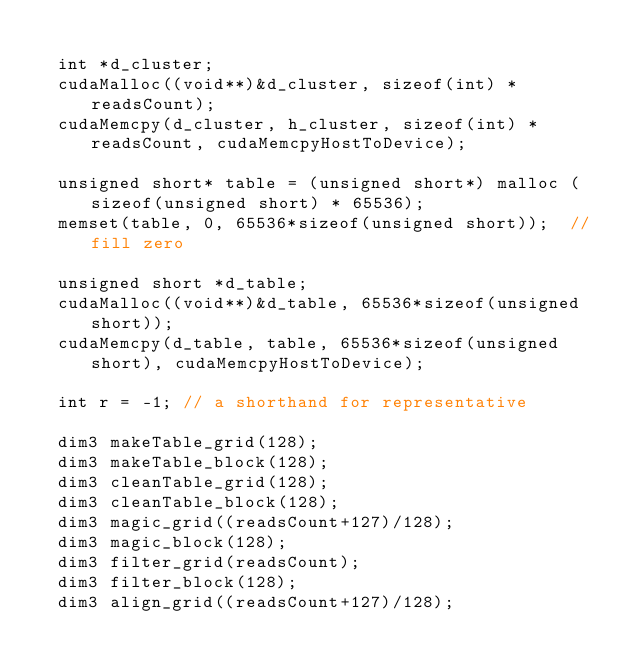<code> <loc_0><loc_0><loc_500><loc_500><_Cuda_>
  int *d_cluster;
  cudaMalloc((void**)&d_cluster, sizeof(int) * readsCount);
  cudaMemcpy(d_cluster, h_cluster, sizeof(int) * readsCount, cudaMemcpyHostToDevice);

  unsigned short* table = (unsigned short*) malloc (sizeof(unsigned short) * 65536);
  memset(table, 0, 65536*sizeof(unsigned short));  // fill zero

  unsigned short *d_table;
  cudaMalloc((void**)&d_table, 65536*sizeof(unsigned short));
  cudaMemcpy(d_table, table, 65536*sizeof(unsigned short), cudaMemcpyHostToDevice);

  int r = -1; // a shorthand for representative

  dim3 makeTable_grid(128);
  dim3 makeTable_block(128);
  dim3 cleanTable_grid(128);
  dim3 cleanTable_block(128);
  dim3 magic_grid((readsCount+127)/128);
  dim3 magic_block(128);
  dim3 filter_grid(readsCount);
  dim3 filter_block(128);
  dim3 align_grid((readsCount+127)/128);</code> 